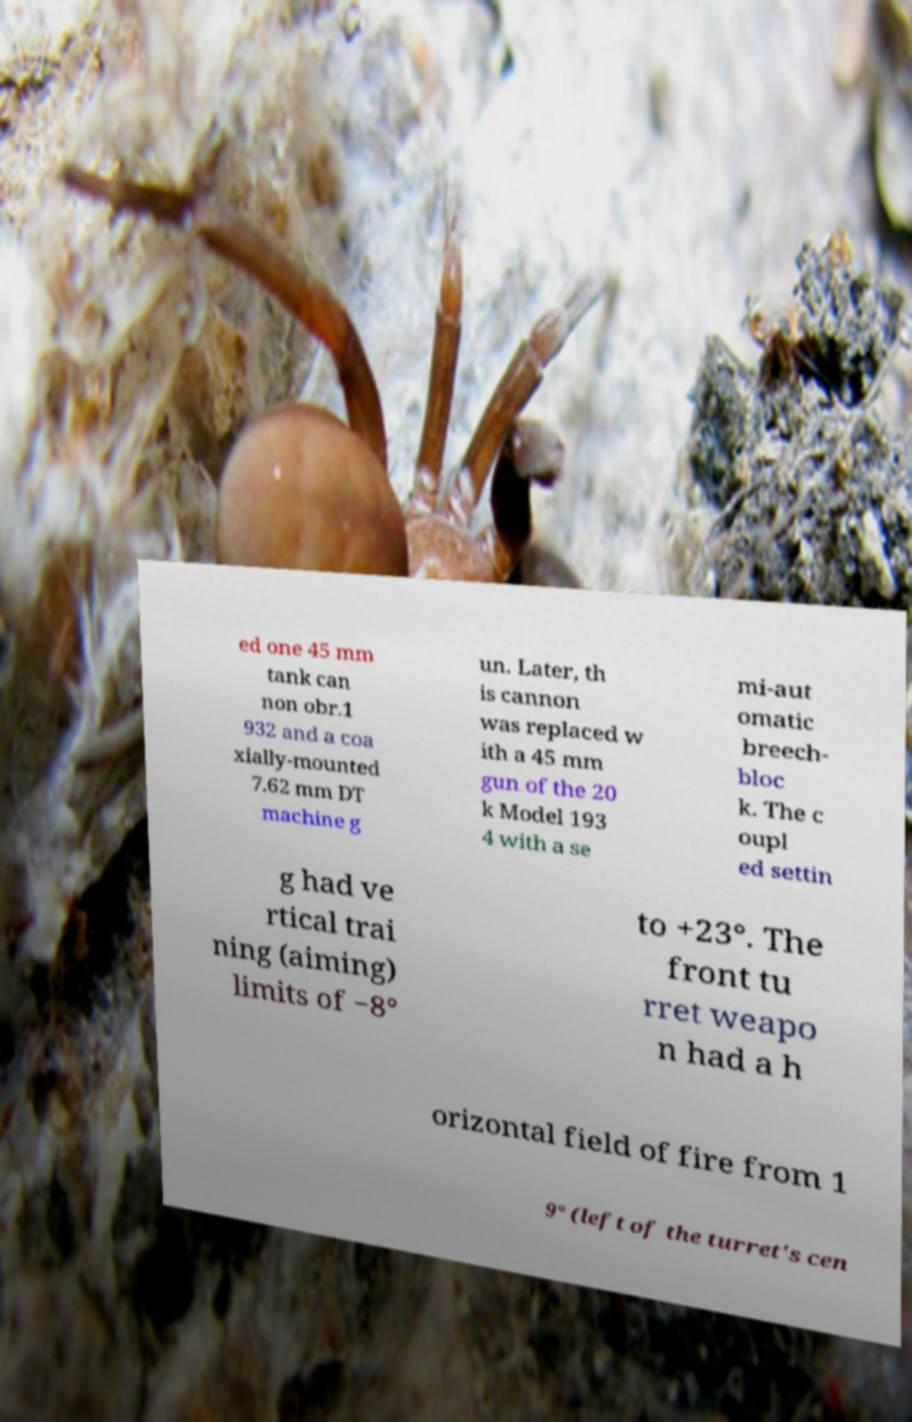Please read and relay the text visible in this image. What does it say? ed one 45 mm tank can non obr.1 932 and a coa xially-mounted 7.62 mm DT machine g un. Later, th is cannon was replaced w ith a 45 mm gun of the 20 k Model 193 4 with a se mi-aut omatic breech- bloc k. The c oupl ed settin g had ve rtical trai ning (aiming) limits of −8° to +23°. The front tu rret weapo n had a h orizontal field of fire from 1 9° (left of the turret's cen 